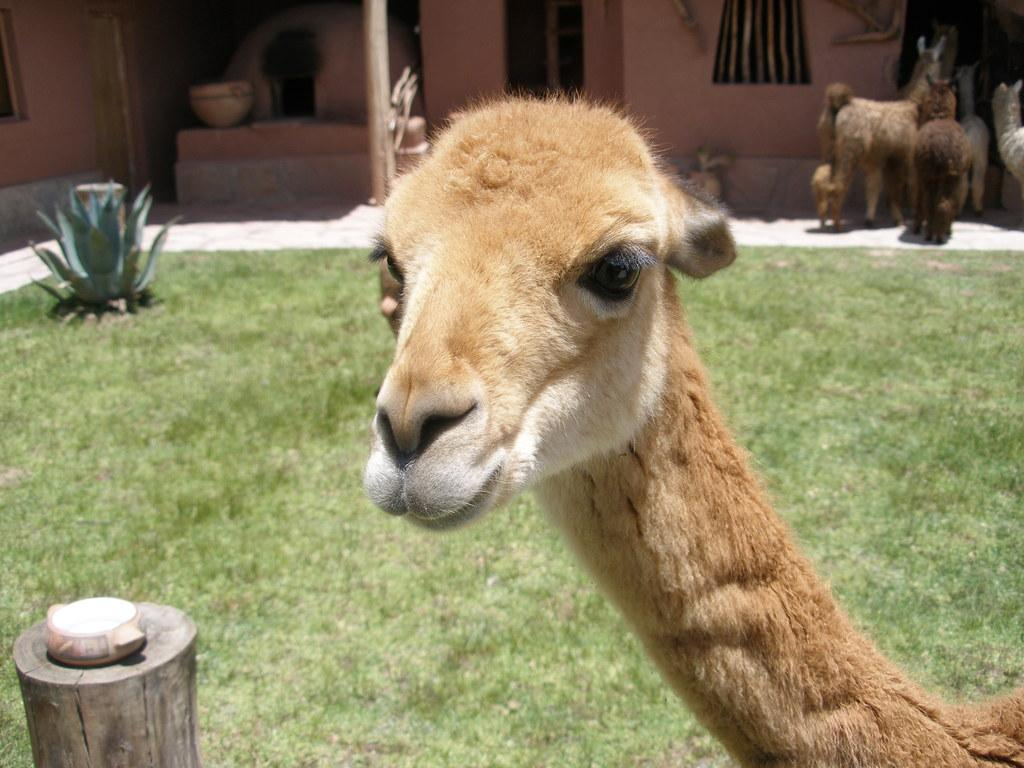What is the main subject of the image? The main subject of the image is a sheep's face. What can be seen on the bottom left of the image? There is a tree pole on the bottom left of the image. What is visible in the background of the image? There is a plant and a house in the background of the image, along with other sheep. What type of square is visible in the image? There is no square present in the image. Can you identify any quartz in the image? There is no quartz present in the image. 